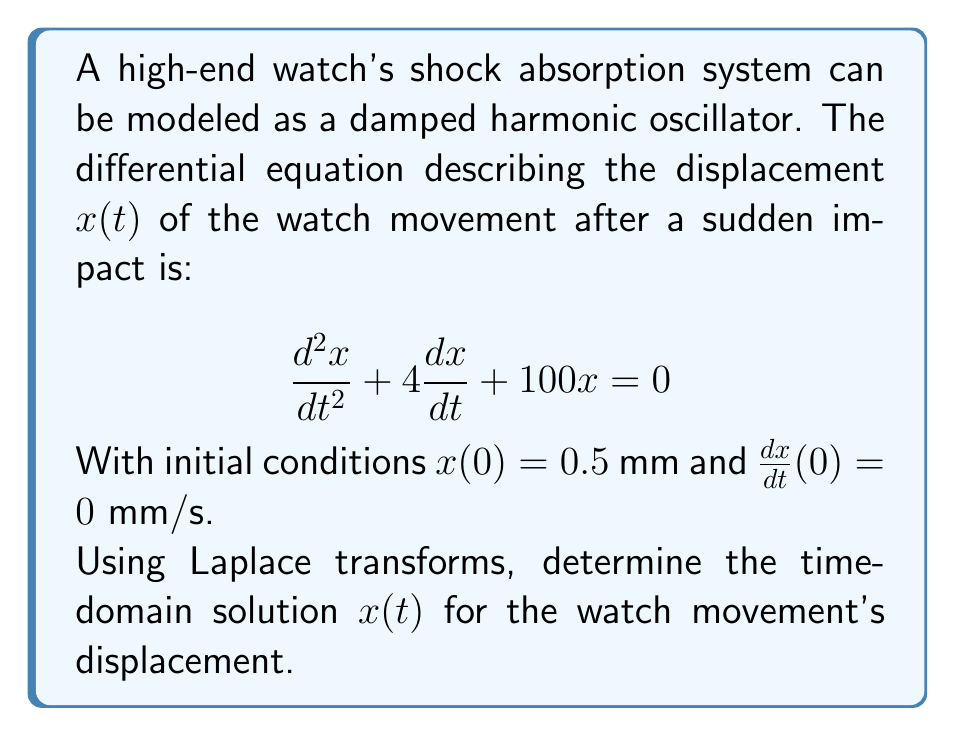Provide a solution to this math problem. Let's solve this step-by-step using Laplace transforms:

1) Take the Laplace transform of both sides of the differential equation:
   $$\mathcal{L}\{x''(t) + 4x'(t) + 100x(t)\} = \mathcal{L}\{0\}$$

2) Using Laplace transform properties:
   $$s^2X(s) - sx(0) - x'(0) + 4[sX(s) - x(0)] + 100X(s) = 0$$

3) Substitute the initial conditions $x(0) = 0.5$ and $x'(0) = 0$:
   $$s^2X(s) - 0.5s + 4sX(s) - 2 + 100X(s) = 0$$

4) Collect terms with $X(s)$:
   $$(s^2 + 4s + 100)X(s) = 0.5s + 2$$

5) Solve for $X(s)$:
   $$X(s) = \frac{0.5s + 2}{s^2 + 4s + 100}$$

6) Factor the denominator:
   $$X(s) = \frac{0.5s + 2}{(s+2)^2 + 96}$$

7) This is in the form of a damped sinusoidal response. The inverse Laplace transform is:
   $$x(t) = e^{-2t}(A\cos(4\sqrt{6}t) + B\sin(4\sqrt{6}t))$$

8) To find $A$ and $B$, we can expand the fraction in partial fractions:
   $$\frac{0.5s + 2}{(s+2)^2 + 96} = \frac{0.5(s+2)}{(s+2)^2 + 96} + \frac{1}{4\sqrt{6}} \cdot \frac{4\sqrt{6}}{(s+2)^2 + 96}$$

9) Comparing with the standard form, we get:
   $$A = 0.5 \text{ and } B = \frac{1}{4\sqrt{6}}$$

10) Therefore, the final time-domain solution is:
    $$x(t) = e^{-2t}(0.5\cos(4\sqrt{6}t) + \frac{1}{4\sqrt{6}}\sin(4\sqrt{6}t))$$
Answer: $$x(t) = e^{-2t}(0.5\cos(4\sqrt{6}t) + \frac{1}{4\sqrt{6}}\sin(4\sqrt{6}t))$$ 